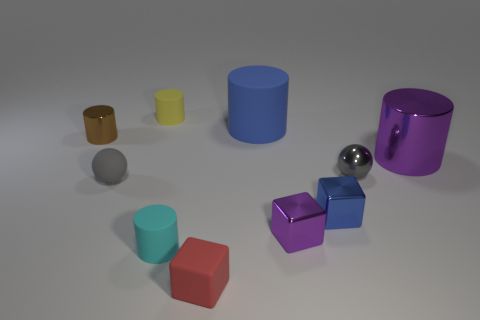Subtract all cyan cylinders. How many cylinders are left? 4 Subtract all tiny brown cylinders. How many cylinders are left? 4 Subtract all red cylinders. Subtract all yellow balls. How many cylinders are left? 5 Subtract all blocks. How many objects are left? 7 Subtract all spheres. Subtract all tiny brown cylinders. How many objects are left? 7 Add 7 small red objects. How many small red objects are left? 8 Add 1 brown shiny blocks. How many brown shiny blocks exist? 1 Subtract 0 cyan cubes. How many objects are left? 10 